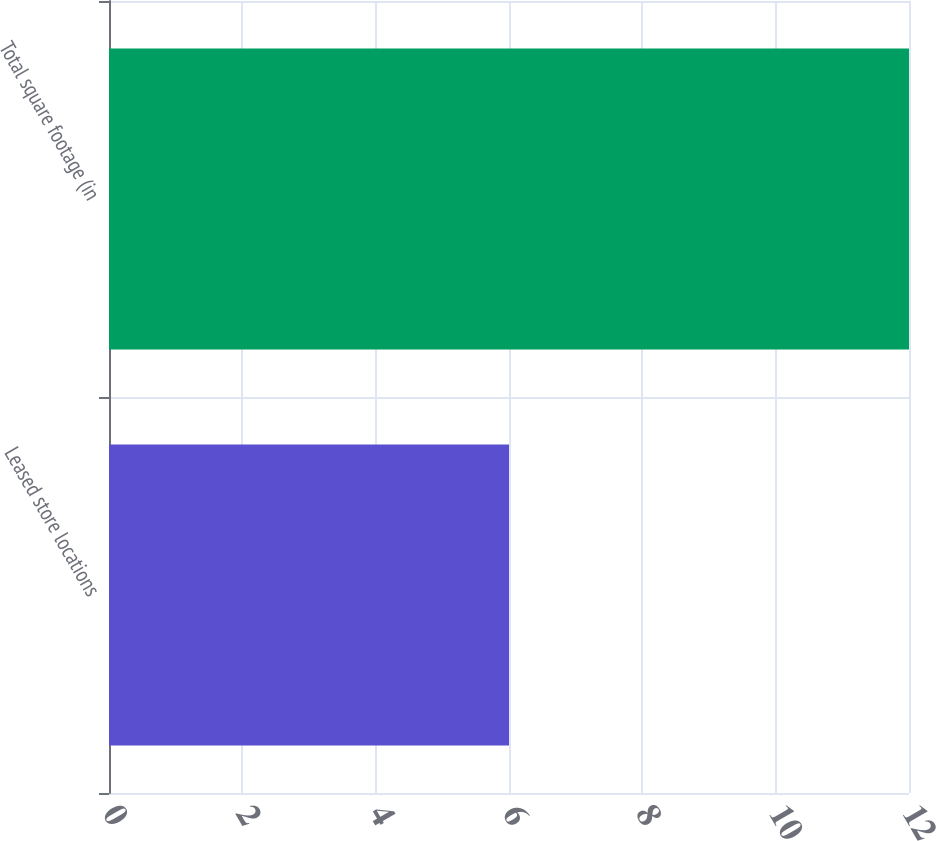Convert chart. <chart><loc_0><loc_0><loc_500><loc_500><bar_chart><fcel>Leased store locations<fcel>Total square footage (in<nl><fcel>6<fcel>12<nl></chart> 